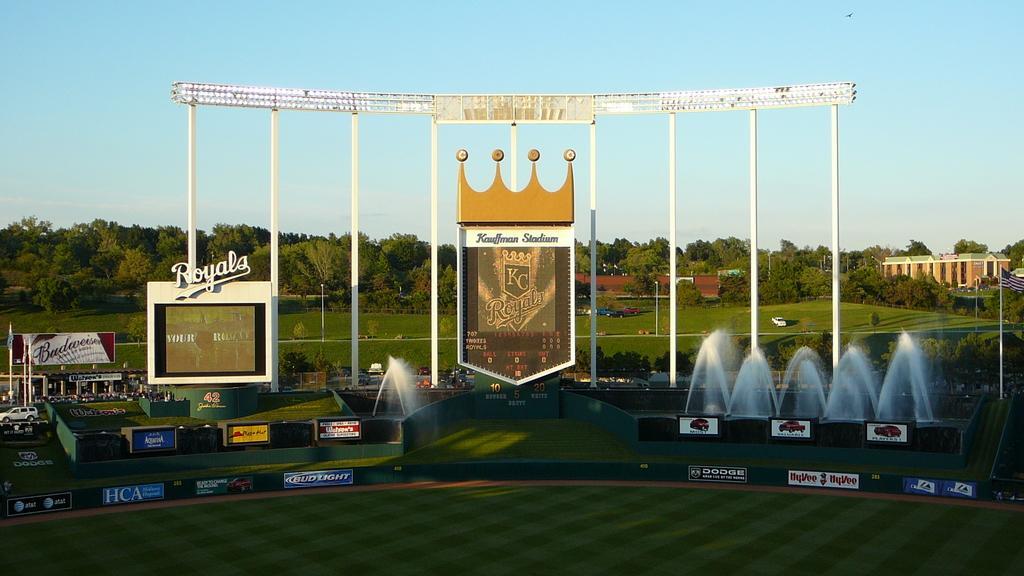Describe this image in one or two sentences. In the middle of this image, there is an arch on a ground, on which, there are waterfalls, hoardings, vehicles, buildings, trees and grass. In the background, there are clouds in the blue sky. 